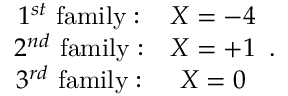<formula> <loc_0><loc_0><loc_500><loc_500>\begin{array} { c c } { { 1 ^ { s t } \ f a m i l y \colon } } & { X = - 4 } \\ { { 2 ^ { n d } \ f a m i l y \colon } } & { X = + 1 } \\ { { 3 ^ { r d } \ f a m i l y \colon } } & { X = 0 } \end{array} .</formula> 